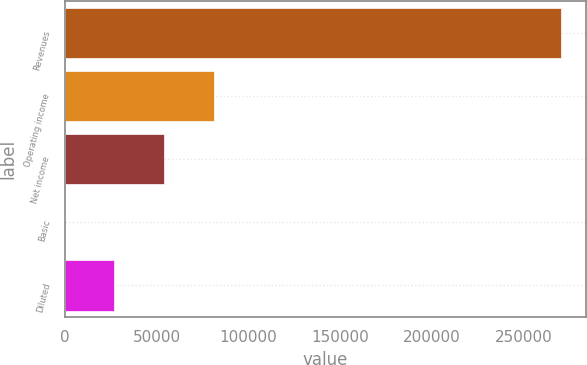Convert chart. <chart><loc_0><loc_0><loc_500><loc_500><bar_chart><fcel>Revenues<fcel>Operating income<fcel>Net income<fcel>Basic<fcel>Diluted<nl><fcel>269971<fcel>80991.4<fcel>53994.3<fcel>0.18<fcel>26997.3<nl></chart> 